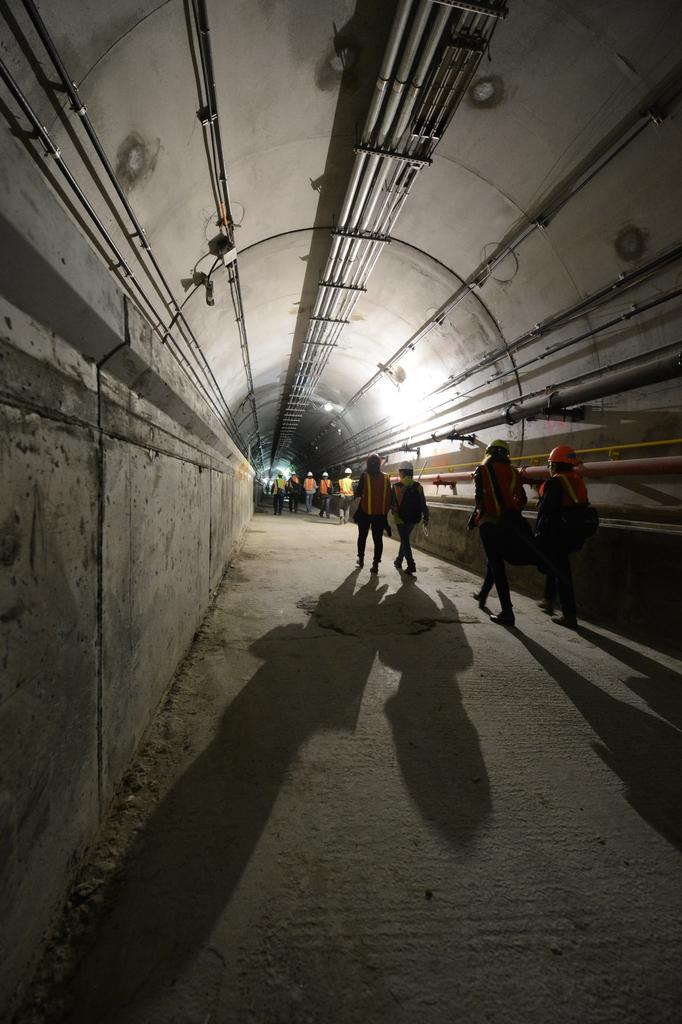What is the main setting of the image? The image shows the inside of a tunnel. What can be seen within the tunnel? There are pipes visible in the tunnel. Is the tunnel completely dark, or is there any light source? There is light in the tunnel. What are the people in the image doing? People are walking on a pathway in the tunnel. What is the temper of the thing in the tunnel? There is no "thing" mentioned in the image, and the concept of temper does not apply to the objects or people present. 